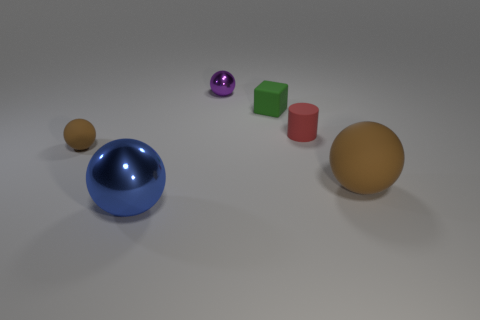Is the number of small brown balls that are to the right of the blue metallic object less than the number of red matte things that are to the right of the large rubber ball? Upon inspecting the image, there are in fact no small brown balls to the right of the blue metallic object—instead, a purple sphere and two cubes, one green and one red, can be seen. There is also no large rubber ball present in the image visible to provide a comparison with red matte objects. Therefore, the question is based on a misinterpretation of the items in the image. 